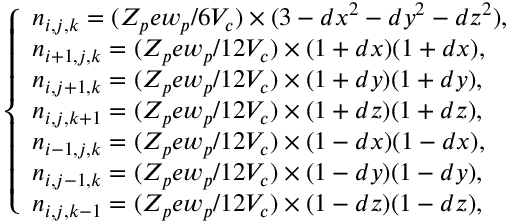Convert formula to latex. <formula><loc_0><loc_0><loc_500><loc_500>\left \{ \begin{array} { l l } { n _ { i , j , k } = ( Z _ { p } e w _ { p } / 6 V _ { c } ) \times ( 3 - d x ^ { 2 } - d y ^ { 2 } - d z ^ { 2 } ) , } \\ { n _ { i + 1 , j , k } = ( Z _ { p } e w _ { p } / 1 2 V _ { c } ) \times ( 1 + d x ) ( 1 + d x ) , } \\ { n _ { i , j + 1 , k } = ( Z _ { p } e w _ { p } / 1 2 V _ { c } ) \times ( 1 + d y ) ( 1 + d y ) , } \\ { n _ { i , j , k + 1 } = ( Z _ { p } e w _ { p } / 1 2 V _ { c } ) \times ( 1 + d z ) ( 1 + d z ) , } \\ { n _ { i - 1 , j , k } = ( Z _ { p } e w _ { p } / 1 2 V _ { c } ) \times ( 1 - d x ) ( 1 - d x ) , } \\ { n _ { i , j - 1 , k } = ( Z _ { p } e w _ { p } / 1 2 V _ { c } ) \times ( 1 - d y ) ( 1 - d y ) , } \\ { n _ { i , j , k - 1 } = ( Z _ { p } e w _ { p } / 1 2 V _ { c } ) \times ( 1 - d z ) ( 1 - d z ) , } \end{array}</formula> 